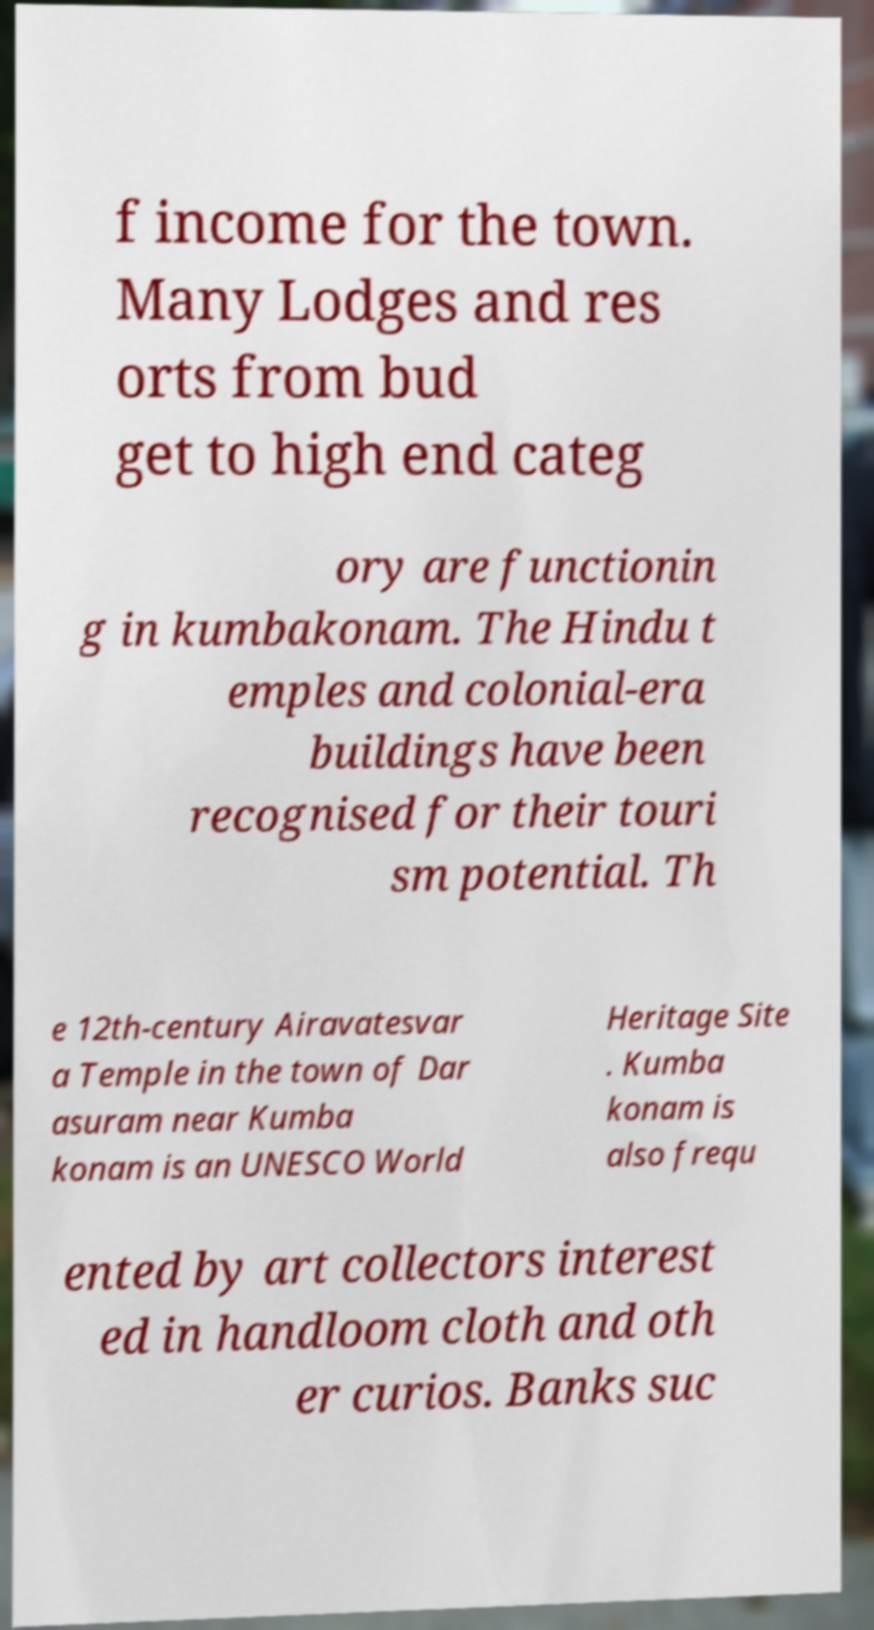I need the written content from this picture converted into text. Can you do that? f income for the town. Many Lodges and res orts from bud get to high end categ ory are functionin g in kumbakonam. The Hindu t emples and colonial-era buildings have been recognised for their touri sm potential. Th e 12th-century Airavatesvar a Temple in the town of Dar asuram near Kumba konam is an UNESCO World Heritage Site . Kumba konam is also frequ ented by art collectors interest ed in handloom cloth and oth er curios. Banks suc 